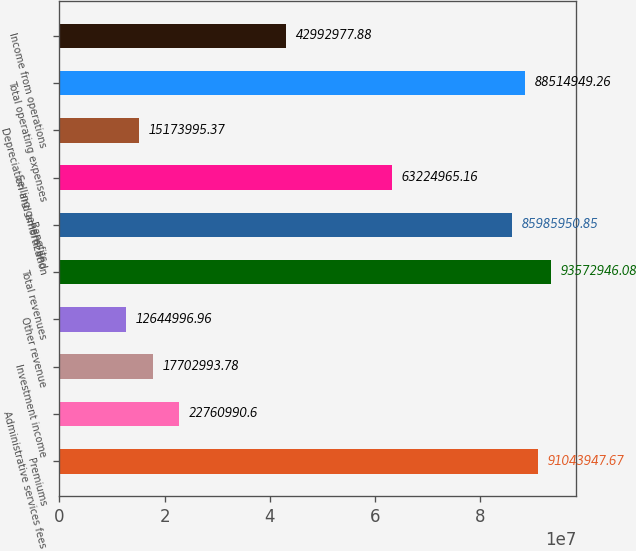<chart> <loc_0><loc_0><loc_500><loc_500><bar_chart><fcel>Premiums<fcel>Administrative services fees<fcel>Investment income<fcel>Other revenue<fcel>Total revenues<fcel>Benefits<fcel>Selling general and<fcel>Depreciation and amortization<fcel>Total operating expenses<fcel>Income from operations<nl><fcel>9.10439e+07<fcel>2.2761e+07<fcel>1.7703e+07<fcel>1.2645e+07<fcel>9.35729e+07<fcel>8.5986e+07<fcel>6.3225e+07<fcel>1.5174e+07<fcel>8.85149e+07<fcel>4.2993e+07<nl></chart> 